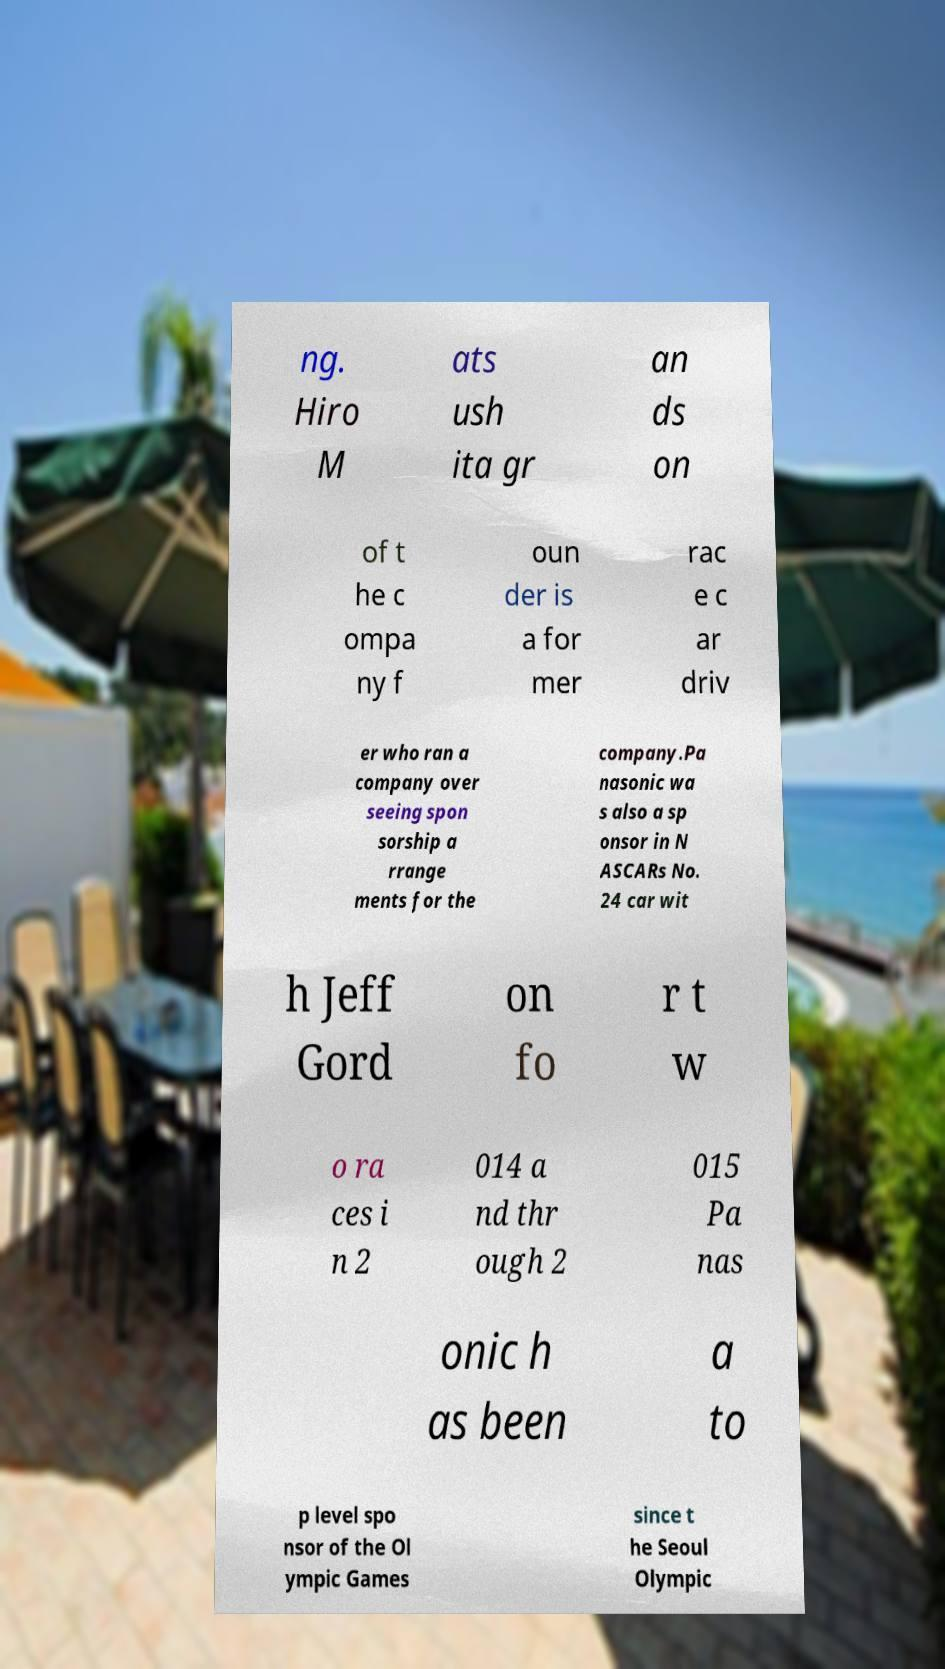Could you extract and type out the text from this image? ng. Hiro M ats ush ita gr an ds on of t he c ompa ny f oun der is a for mer rac e c ar driv er who ran a company over seeing spon sorship a rrange ments for the company.Pa nasonic wa s also a sp onsor in N ASCARs No. 24 car wit h Jeff Gord on fo r t w o ra ces i n 2 014 a nd thr ough 2 015 Pa nas onic h as been a to p level spo nsor of the Ol ympic Games since t he Seoul Olympic 